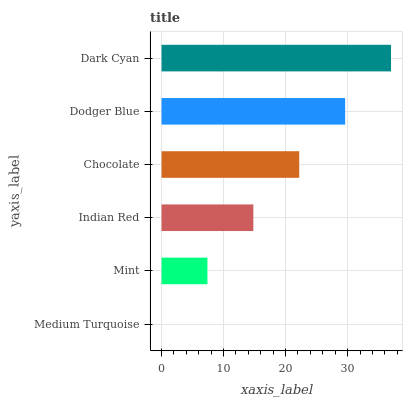Is Medium Turquoise the minimum?
Answer yes or no. Yes. Is Dark Cyan the maximum?
Answer yes or no. Yes. Is Mint the minimum?
Answer yes or no. No. Is Mint the maximum?
Answer yes or no. No. Is Mint greater than Medium Turquoise?
Answer yes or no. Yes. Is Medium Turquoise less than Mint?
Answer yes or no. Yes. Is Medium Turquoise greater than Mint?
Answer yes or no. No. Is Mint less than Medium Turquoise?
Answer yes or no. No. Is Chocolate the high median?
Answer yes or no. Yes. Is Indian Red the low median?
Answer yes or no. Yes. Is Dodger Blue the high median?
Answer yes or no. No. Is Chocolate the low median?
Answer yes or no. No. 